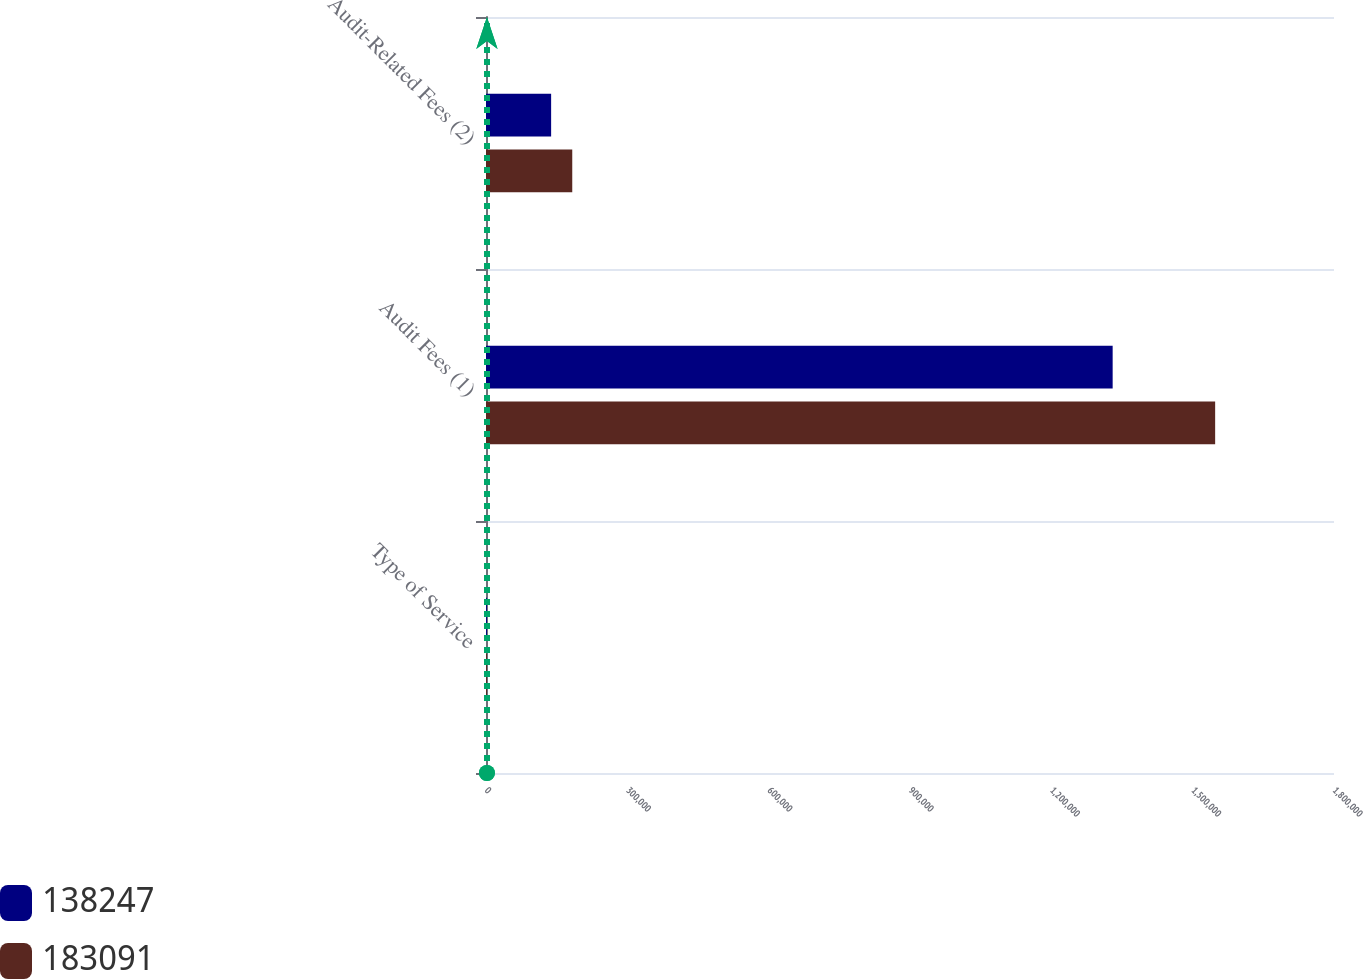<chart> <loc_0><loc_0><loc_500><loc_500><stacked_bar_chart><ecel><fcel>Type of Service<fcel>Audit Fees (1)<fcel>Audit-Related Fees (2)<nl><fcel>138247<fcel>2010<fcel>1.33017e+06<fcel>138247<nl><fcel>183091<fcel>2011<fcel>1.54772e+06<fcel>183091<nl></chart> 